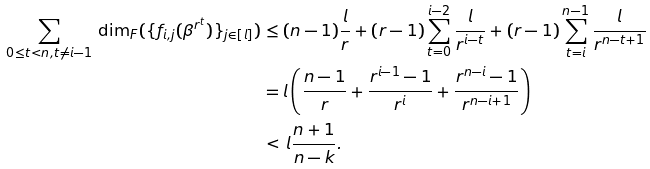Convert formula to latex. <formula><loc_0><loc_0><loc_500><loc_500>\sum _ { 0 \leq t < n , t \neq i - 1 } \, { \dim } _ { F } ( \{ f _ { i , j } ( \beta ^ { r ^ { t } } ) \} _ { j \in [ l ] } ) & \leq ( n - 1 ) \frac { l } { r } + ( r - 1 ) \sum _ { t = 0 } ^ { i - 2 } \frac { l } { r ^ { i - t } } + ( r - 1 ) \sum _ { t = i } ^ { n - 1 } \frac { l } { r ^ { n - t + 1 } } \\ & = l \left ( \frac { n - 1 } { r } + \frac { r ^ { i - 1 } - 1 } { r ^ { i } } + \frac { r ^ { n - i } - 1 } { r ^ { n - i + 1 } } \right ) \\ & < \, l \frac { n + 1 } { n - k } .</formula> 